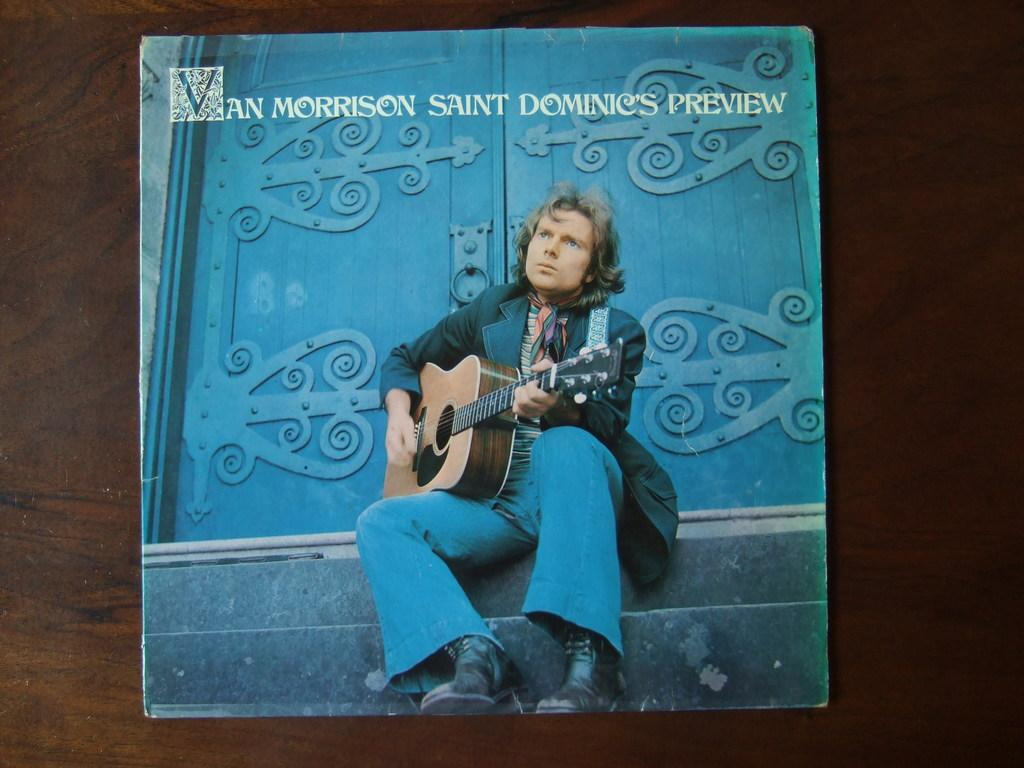What is the main subject of the image? The main subject of the image is a person. What is the person wearing? The person is wearing clothes. What is the person doing in the image? The person is playing a guitar. Where is the person located in the image? The person is in front of a door. What can be seen at the top of the image? There is text at the top of the image. Can you tell me what type of dog is sitting next to the person in the image? There is no dog present in the image; it only features a person playing a guitar in front of a door. What advice is the person giving in the image? The image does not depict the person giving any advice; it simply shows them playing a guitar. 